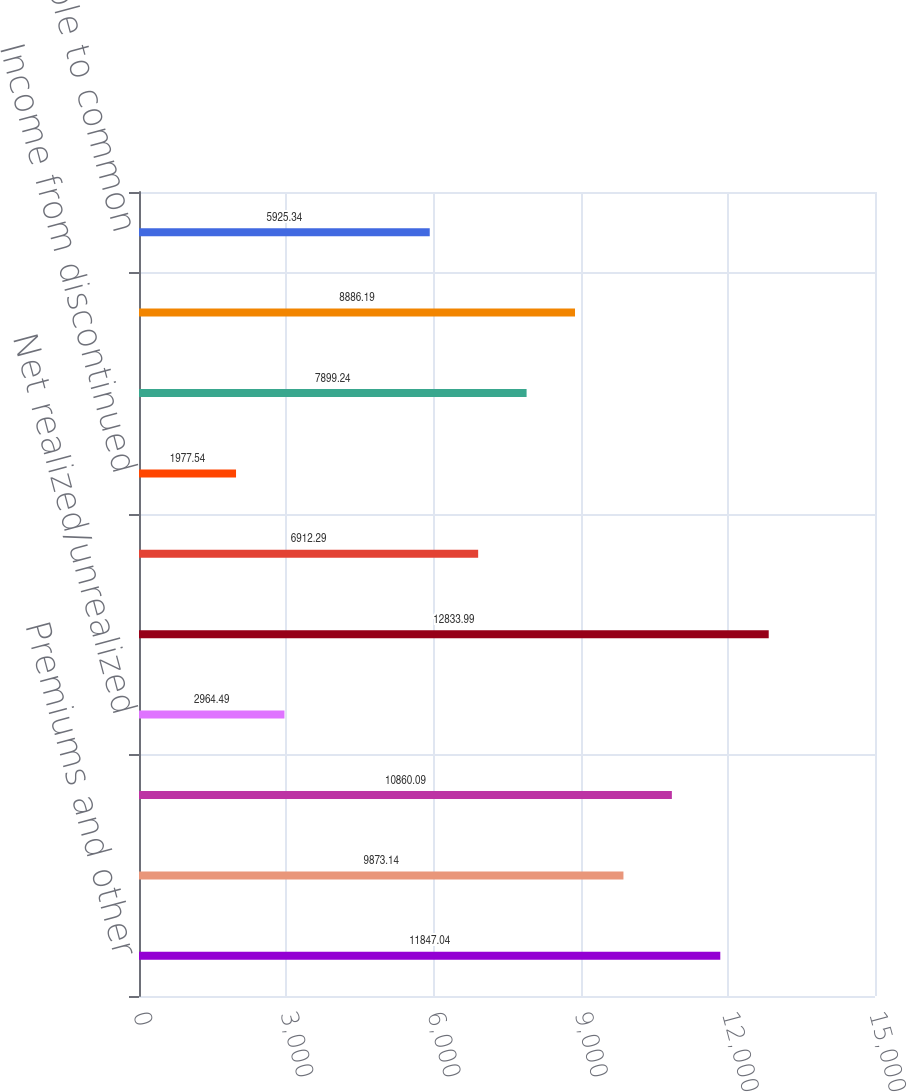<chart> <loc_0><loc_0><loc_500><loc_500><bar_chart><fcel>Premiums and other<fcel>Fees and other revenues<fcel>Net investment income<fcel>Net realized/unrealized<fcel>Total revenues<fcel>Income from continuing<fcel>Income from discontinued<fcel>Income before cumulative<fcel>Net income<fcel>Net income available to common<nl><fcel>11847<fcel>9873.14<fcel>10860.1<fcel>2964.49<fcel>12834<fcel>6912.29<fcel>1977.54<fcel>7899.24<fcel>8886.19<fcel>5925.34<nl></chart> 